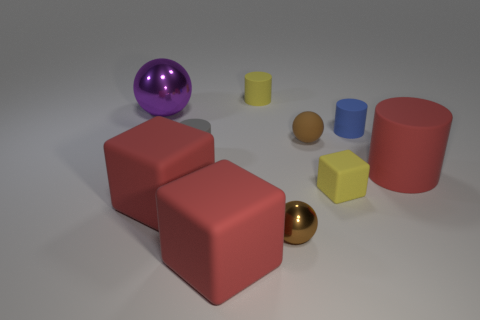What material is the other sphere that is the same color as the small matte sphere?
Provide a succinct answer. Metal. What color is the big matte object that is the same shape as the small gray thing?
Keep it short and to the point. Red. The tiny object that is both behind the small shiny object and in front of the gray cylinder has what shape?
Provide a succinct answer. Cube. How many gray objects are small things or big metal things?
Offer a very short reply. 1. There is a matte thing left of the tiny gray cylinder; is its size the same as the red cylinder that is on the right side of the small yellow matte cylinder?
Your response must be concise. Yes. What number of objects are either tiny balls or brown blocks?
Offer a terse response. 2. Is there a big red matte thing of the same shape as the big purple metallic thing?
Offer a very short reply. No. Are there fewer red cylinders than cylinders?
Ensure brevity in your answer.  Yes. Do the small shiny object and the blue thing have the same shape?
Ensure brevity in your answer.  No. How many objects are either tiny brown rubber objects or blocks that are right of the large metallic sphere?
Your answer should be compact. 4. 